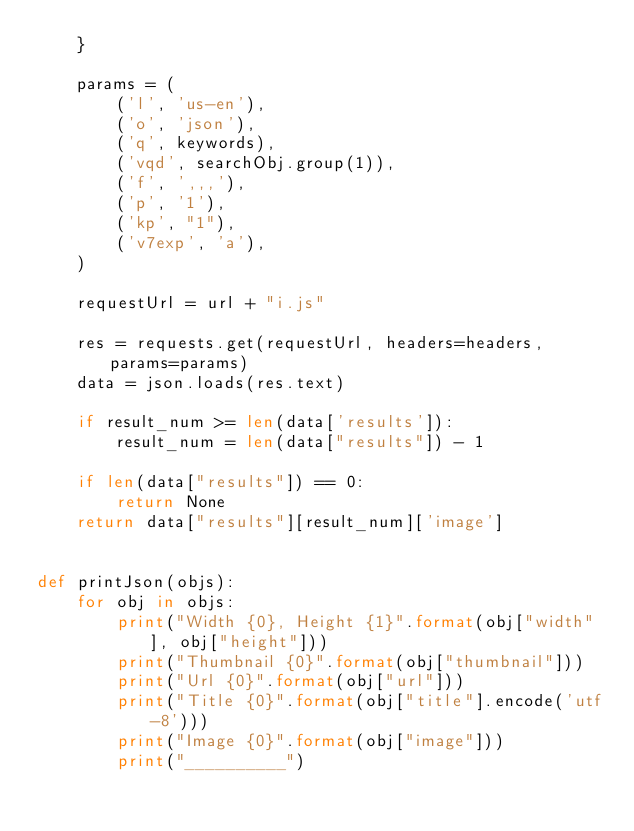<code> <loc_0><loc_0><loc_500><loc_500><_Python_>    }

    params = (
        ('l', 'us-en'),
        ('o', 'json'),
        ('q', keywords),
        ('vqd', searchObj.group(1)),
        ('f', ',,,'),
        ('p', '1'),
        ('kp', "1"),
        ('v7exp', 'a'),
    )

    requestUrl = url + "i.js"

    res = requests.get(requestUrl, headers=headers, params=params)
    data = json.loads(res.text)

    if result_num >= len(data['results']):
        result_num = len(data["results"]) - 1

    if len(data["results"]) == 0:
        return None
    return data["results"][result_num]['image']


def printJson(objs):
    for obj in objs:
        print("Width {0}, Height {1}".format(obj["width"], obj["height"]))
        print("Thumbnail {0}".format(obj["thumbnail"]))
        print("Url {0}".format(obj["url"]))
        print("Title {0}".format(obj["title"].encode('utf-8')))
        print("Image {0}".format(obj["image"]))
        print("__________")
</code> 